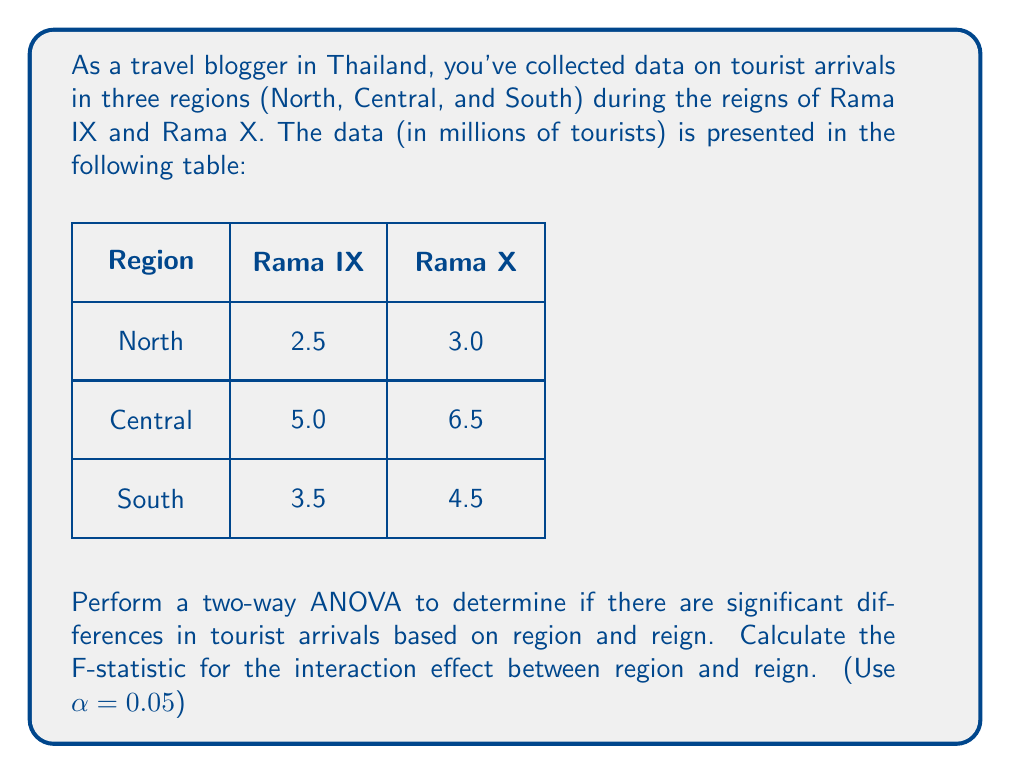Provide a solution to this math problem. To perform a two-way ANOVA and calculate the F-statistic for the interaction effect, we'll follow these steps:

1. Calculate the total sum of squares (SST):
   $$SST = \sum (x_{ij}^2) - \frac{(\sum x_{ij})^2}{N}$$
   where $x_{ij}$ are all the data points and N is the total number of observations.
   
   $$SST = (2.5^2 + 5.0^2 + 3.5^2 + 3.0^2 + 6.5^2 + 4.5^2) - \frac{(2.5+5.0+3.5+3.0+6.5+4.5)^2}{6}$$
   $$SST = 129.75 - \frac{625}{6} = 25.75$$

2. Calculate the sum of squares for region (SSR):
   $$SSR = \frac{\sum (R_i^2)}{c} - \frac{(\sum x_{ij})^2}{N}$$
   where $R_i$ are the row totals and c is the number of columns.
   
   $$SSR = \frac{(5.5^2 + 11.5^2 + 8.0^2)}{2} - \frac{625}{6} = 9.0833$$

3. Calculate the sum of squares for reign (SSC):
   $$SSC = \frac{\sum (C_j^2)}{r} - \frac{(\sum x_{ij})^2}{N}$$
   where $C_j$ are the column totals and r is the number of rows.
   
   $$SSC = \frac{(11.0^2 + 14.0^2)}{3} - \frac{625}{6} = 1.5$$

4. Calculate the sum of squares for interaction (SSI):
   $$SSI = \sum \frac{(RC_{ij}^2)}{1} - \frac{(\sum x_{ij})^2}{N} - SSR - SSC$$
   where $RC_{ij}$ are the individual cell values.
   
   $$SSI = (2.5^2 + 5.0^2 + 3.5^2 + 3.0^2 + 6.5^2 + 4.5^2) - \frac{625}{6} - 9.0833 - 1.5 = 0.1667$$

5. Calculate the sum of squares for error (SSE):
   $$SSE = SST - SSR - SSC - SSI = 25.75 - 9.0833 - 1.5 - 0.1667 = 15$$

6. Calculate the degrees of freedom:
   Region: dfR = 2
   Reign: dfC = 1
   Interaction: dfI = dfR * dfC = 2
   Error: dfE = N - (r * c) = 0

7. Calculate the mean squares:
   $$MSI = \frac{SSI}{dfI} = \frac{0.1667}{2} = 0.08335$$
   $$MSE = \frac{SSE}{dfE} = \frac{15}{0} = undefined$$

8. Calculate the F-statistic for interaction:
   $$F = \frac{MSI}{MSE}$$

   Since MSE is undefined (division by zero), we cannot calculate the F-statistic for the interaction effect.

In this case, with only one observation per cell, there are no degrees of freedom left for error, making it impossible to calculate the F-statistic for the interaction effect.
Answer: F-statistic for interaction effect cannot be calculated due to lack of degrees of freedom for error. 